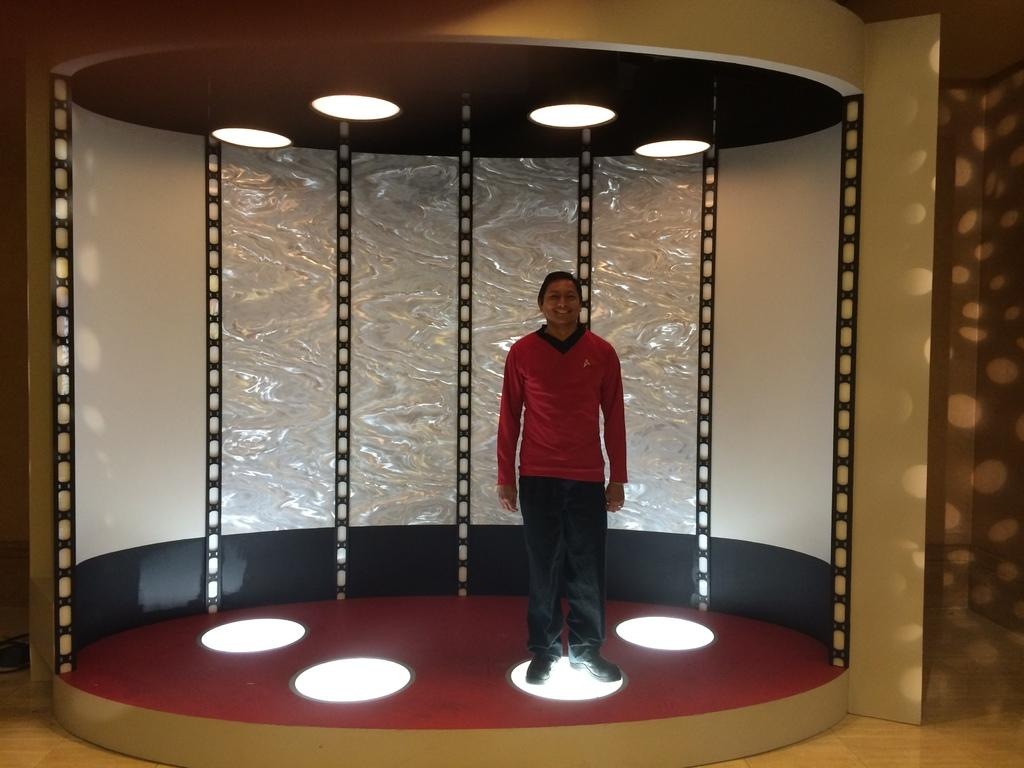What is the man doing in the image? The man is standing on a light fixture. Where is the light fixture located? The light fixture is under a floor. How many lights are above the man? There are four lights above the man, leading to the roof. What can be seen in the background of the image? There is a wall in the background of the image. What type of teeth can be seen in the image? There are no teeth visible in the image. 